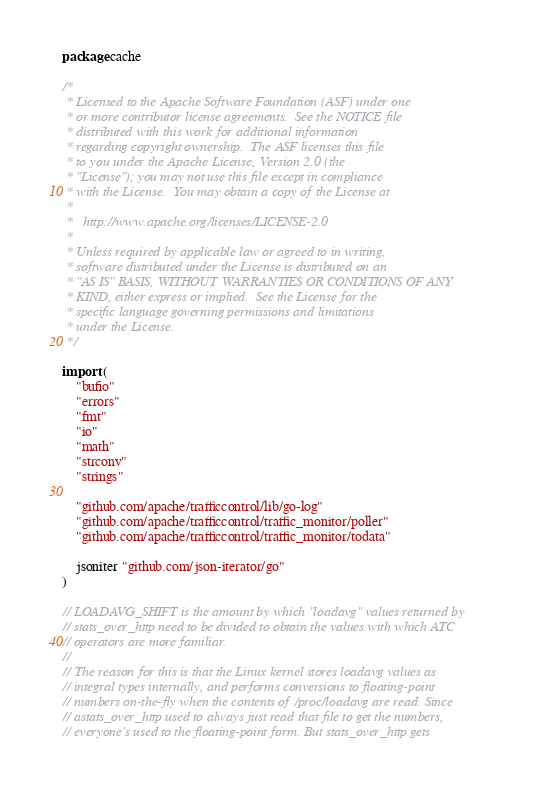Convert code to text. <code><loc_0><loc_0><loc_500><loc_500><_Go_>package cache

/*
 * Licensed to the Apache Software Foundation (ASF) under one
 * or more contributor license agreements.  See the NOTICE file
 * distributed with this work for additional information
 * regarding copyright ownership.  The ASF licenses this file
 * to you under the Apache License, Version 2.0 (the
 * "License"); you may not use this file except in compliance
 * with the License.  You may obtain a copy of the License at
 *
 *   http://www.apache.org/licenses/LICENSE-2.0
 *
 * Unless required by applicable law or agreed to in writing,
 * software distributed under the License is distributed on an
 * "AS IS" BASIS, WITHOUT WARRANTIES OR CONDITIONS OF ANY
 * KIND, either express or implied.  See the License for the
 * specific language governing permissions and limitations
 * under the License.
 */

import (
	"bufio"
	"errors"
	"fmt"
	"io"
	"math"
	"strconv"
	"strings"

	"github.com/apache/trafficcontrol/lib/go-log"
	"github.com/apache/trafficcontrol/traffic_monitor/poller"
	"github.com/apache/trafficcontrol/traffic_monitor/todata"

	jsoniter "github.com/json-iterator/go"
)

// LOADAVG_SHIFT is the amount by which "loadavg" values returned by
// stats_over_http need to be divided to obtain the values with which ATC
// operators are more familiar.
//
// The reason for this is that the Linux kernel stores loadavg values as
// integral types internally, and performs conversions to floating-point
// numbers on-the-fly when the contents of /proc/loadavg are read. Since
// astats_over_http used to always just read that file to get the numbers,
// everyone's used to the floating-point form. But stats_over_http gets</code> 